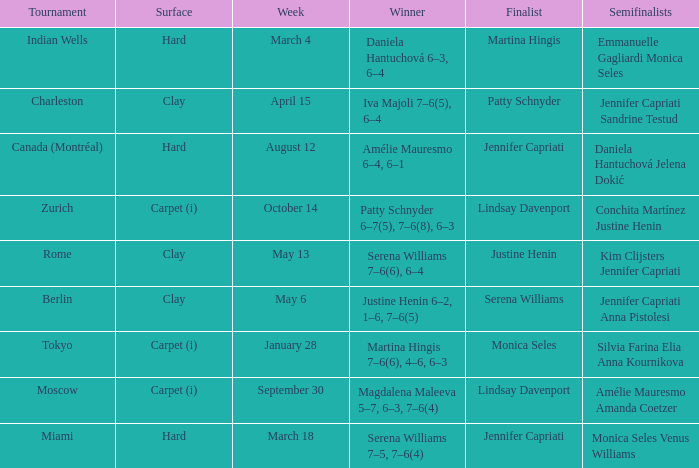What was the surface for finalist Justine Henin? Clay. 